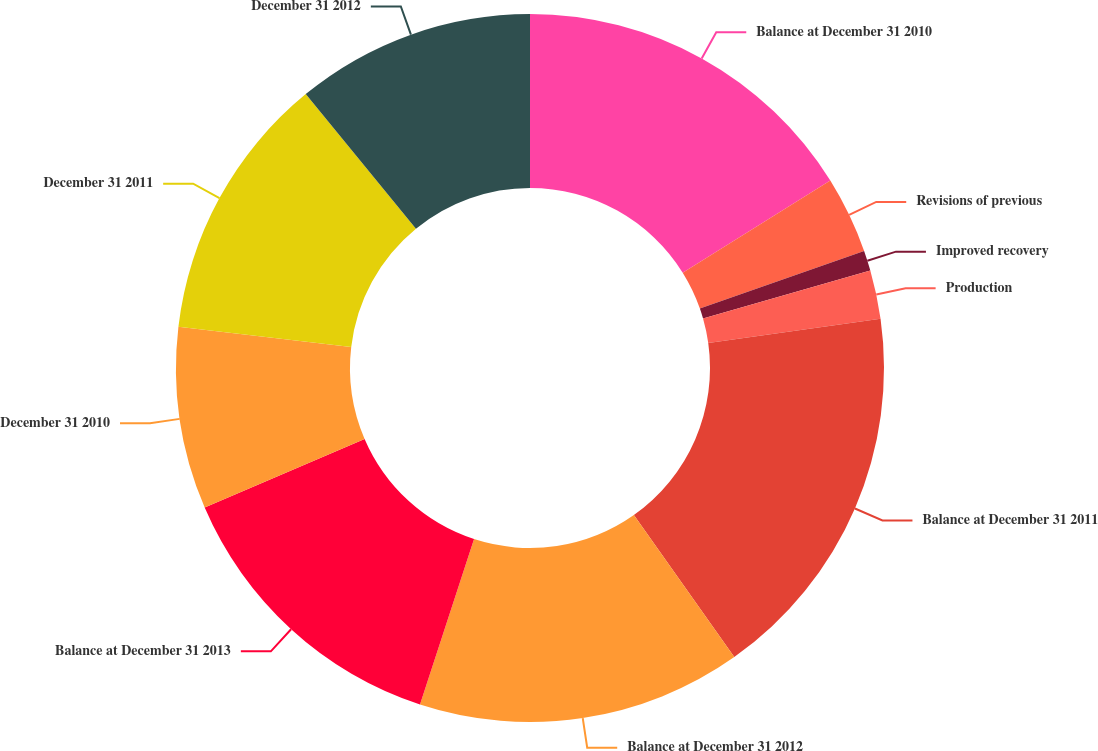Convert chart. <chart><loc_0><loc_0><loc_500><loc_500><pie_chart><fcel>Balance at December 31 2010<fcel>Revisions of previous<fcel>Improved recovery<fcel>Production<fcel>Balance at December 31 2011<fcel>Balance at December 31 2012<fcel>Balance at December 31 2013<fcel>December 31 2010<fcel>December 31 2011<fcel>December 31 2012<nl><fcel>16.12%<fcel>3.52%<fcel>0.92%<fcel>2.22%<fcel>17.43%<fcel>14.82%<fcel>13.52%<fcel>8.31%<fcel>12.22%<fcel>10.92%<nl></chart> 